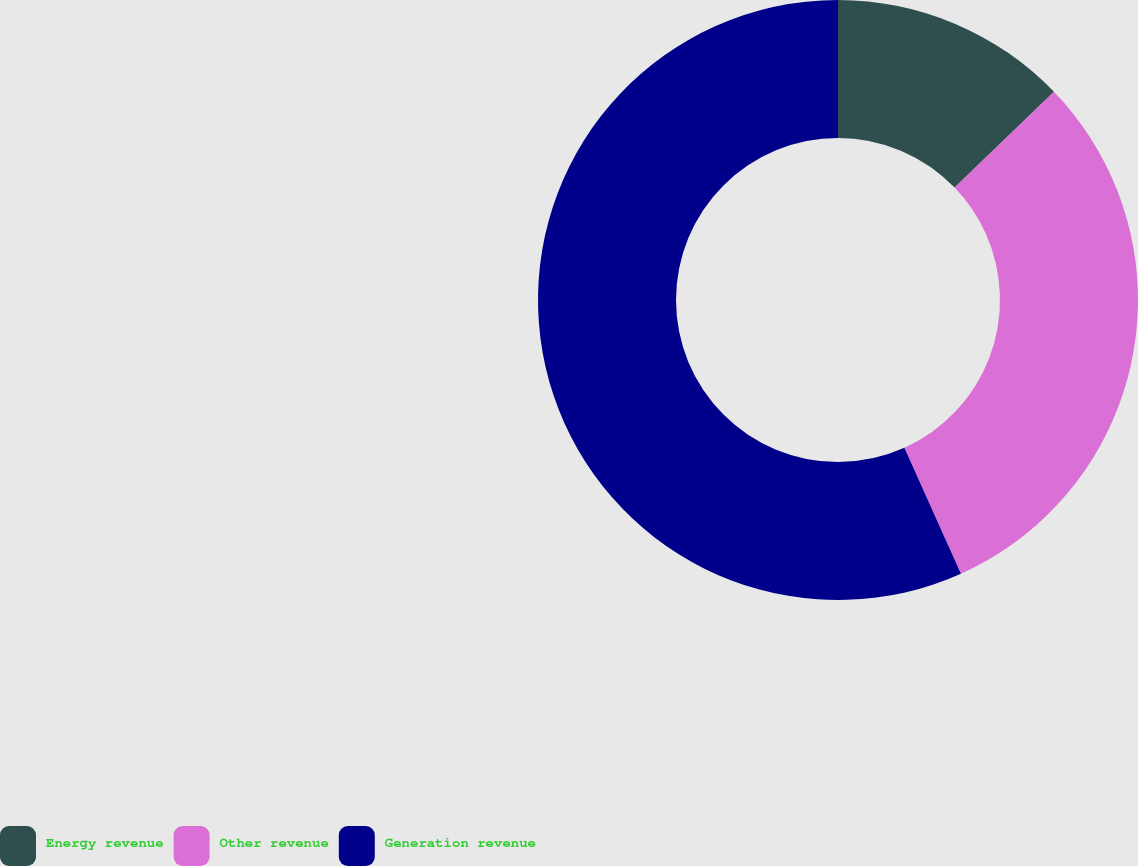Convert chart. <chart><loc_0><loc_0><loc_500><loc_500><pie_chart><fcel>Energy revenue<fcel>Other revenue<fcel>Generation revenue<nl><fcel>12.79%<fcel>30.49%<fcel>56.72%<nl></chart> 